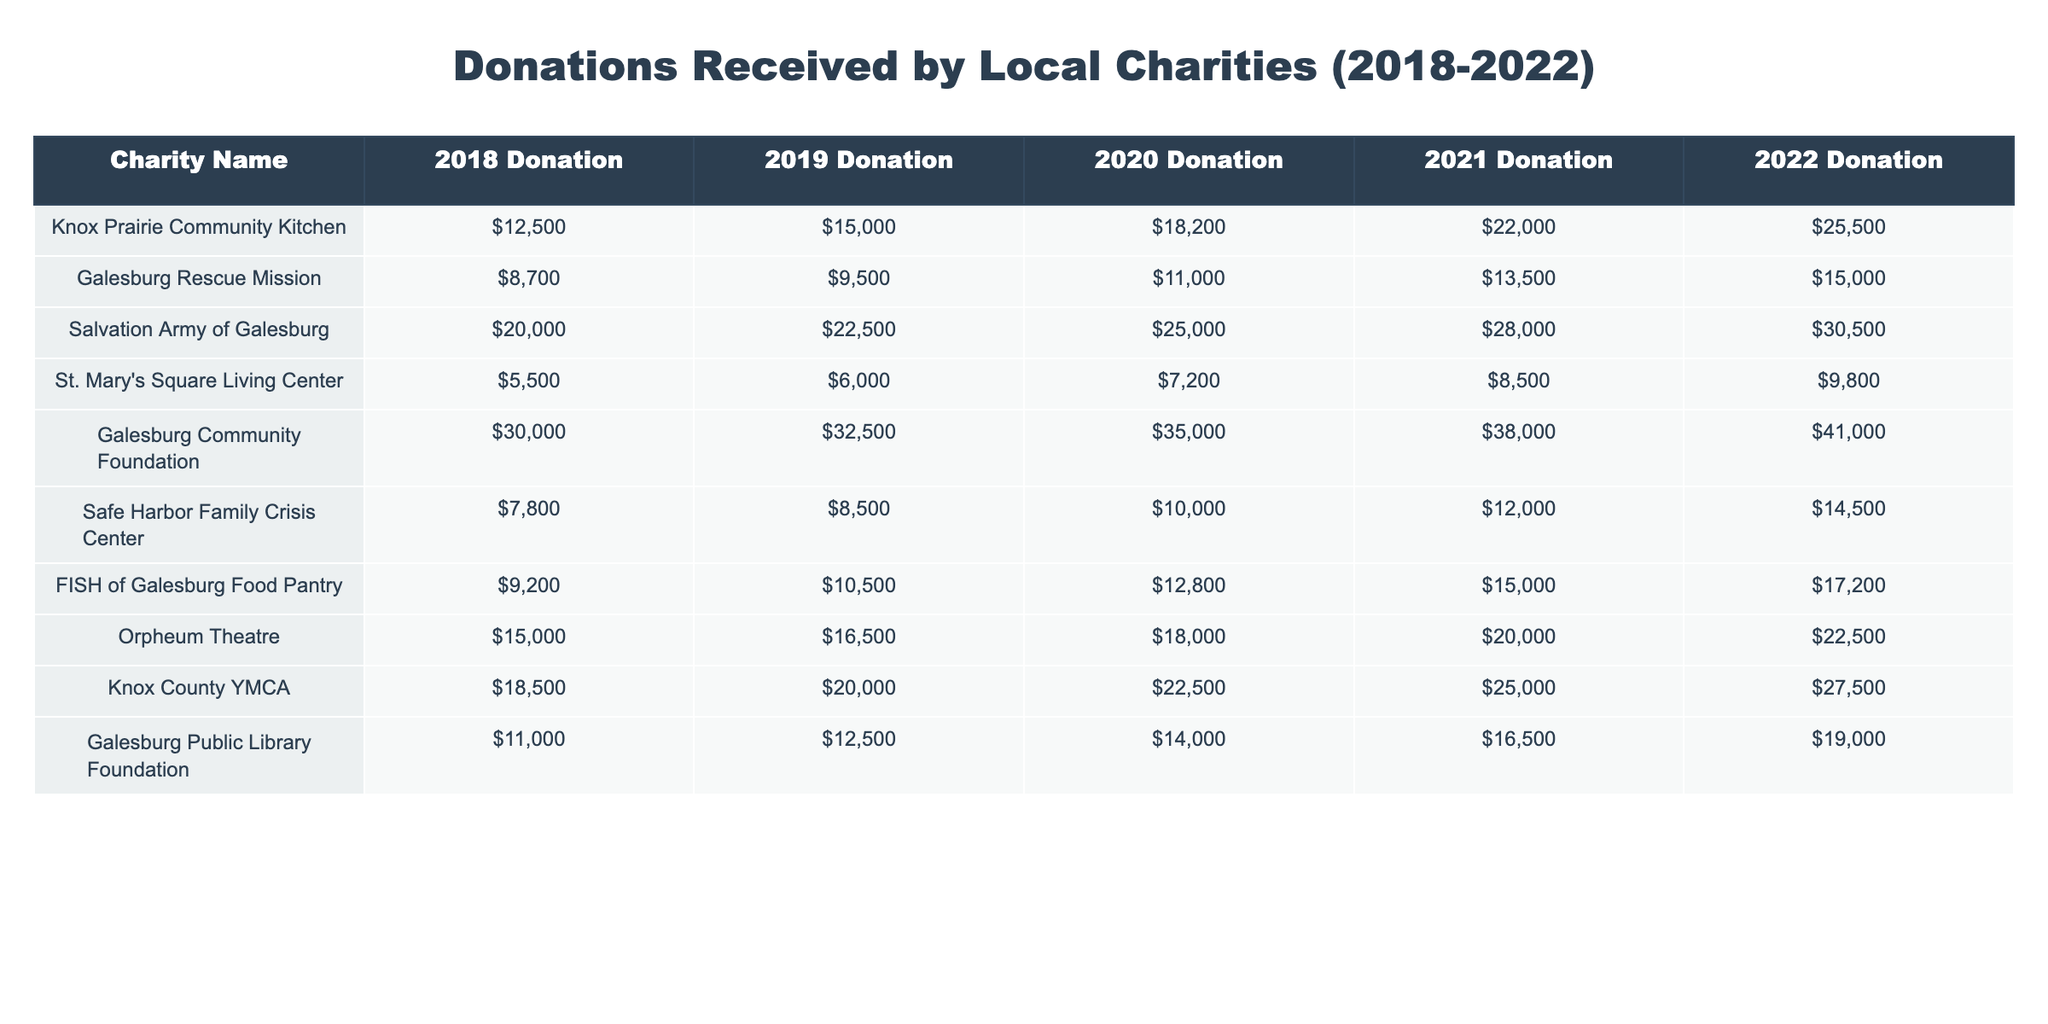What was the total donation received by the Salvation Army of Galesburg from 2018 to 2022? To find the total donations, I will add the donations from each year: 20000 + 22500 + 25000 + 28000 + 30500 = 126000.
Answer: 126000 Which charity received the highest donation in 2021? I will compare the donations for each charity in 2021: Knox Prairie Community Kitchen (22000), Galesburg Rescue Mission (13500), Salvation Army of Galesburg (28000), St. Mary's Square Living Center (8500), Galesburg Community Foundation (38000), Safe Harbor Family Crisis Center (12000), FISH of Galesburg Food Pantry (15000), Orpheum Theatre (20000), Knox County YMCA (25000), and Galesburg Public Library Foundation (16500). The highest donation is from Galesburg Community Foundation at 38000.
Answer: Galesburg Community Foundation How much did FISH of Galesburg Food Pantry increase its donations from 2018 to 2022? To find the increase, I will subtract the 2018 donation from the 2022 donation: 17200 - 9200 = 8000.
Answer: 8000 What is the percentage increase in donations for the Knox County YMCA from 2018 to 2022? First, I will find the increase: 27500 - 18500 = 9000. Then, to find the percentage increase: (9000 / 18500) * 100 = approximately 48.65%.
Answer: Approximately 48.7% Did the St. Mary's Square Living Center receive more than 10000 in donations in any year? I will check each year's donation: 2018 (5500), 2019 (6000), 2020 (7200), 2021 (8500), and 2022 (9800). None of these years exceeded 10000.
Answer: No What is the average annual donation received by the Galesburg Community Foundation over the five years? I will first sum up the donations: 30000 + 32500 + 35000 + 38000 + 41000 = 176500. Then I divide by the number of years: 176500 / 5 = 35300.
Answer: 35300 Which charity had the least total donations over the five years? I will calculate the total donations for each charity and compare them. The totals are: Knox Prairie Community Kitchen (12500 + 15000 + 18200 + 22000 + 25500 = 93200), Galesburg Rescue Mission (8700 + 9500 + 11000 + 13500 + 15000 = 61300), Salvation Army of Galesburg (126000), St. Mary's Square Living Center (5500 + 6000 + 7200 + 8500 + 9800 = 39000), Galesburg Community Foundation (176500), Safe Harbor Family Crisis Center (7800 + 8500 + 10000 + 12000 + 14500 = 54000), FISH of Galesburg Food Pantry (9200 + 10500 + 12800 + 15000 + 17200 = 64700), Orpheum Theatre (15000 + 16500 + 18000 + 20000 + 22500 = 112000), Knox County YMCA (18500 + 20000 + 22500 + 25000 + 27500 = 133500), Galesburg Public Library Foundation (11000 + 12500 + 14000 + 16500 + 19000 = 73000). The least total is from St. Mary's Square Living Center at 39000.
Answer: St. Mary's Square Living Center How much more did Galesburg Community Foundation donate in 2022 compared to FISH of Galesburg Food Pantry? I will find the 2022 donations for both charities: Galesburg Community Foundation (41000) and FISH of Galesburg Food Pantry (17200). The difference is 41000 - 17200 = 23800.
Answer: 23800 What is the total amount contributed to all charities in 2020? I will add the donations for each charity in 2020: Knox Prairie Community Kitchen (18200) + Galesburg Rescue Mission (11000) + Salvation Army of Galesburg (25000) + St. Mary's Square Living Center (7200) + Galesburg Community Foundation (35000) + Safe Harbor Family Crisis Center (10000) + FISH of Galesburg Food Pantry (12800) + Orpheum Theatre (18000) + Knox County YMCA (22500) + Galesburg Public Library Foundation (14000). The total is 18200 + 11000 + 25000 + 7200 + 35000 + 10000 + 12800 + 18000 + 22500 + 14000 = 156700.
Answer: 156700 Is the total amount received by the Galesburg Rescue Mission over the five years greater than that of St. Mary's Square Living Center? First, I will find the total for Galesburg Rescue Mission: 8700 + 9500 + 11000 + 13500 + 15000 = 60000. Then for St. Mary's Square Living Center: 5500 + 6000 + 7200 + 8500 + 9800 = 39000. Comparing these, 60000 is greater than 39000.
Answer: Yes 